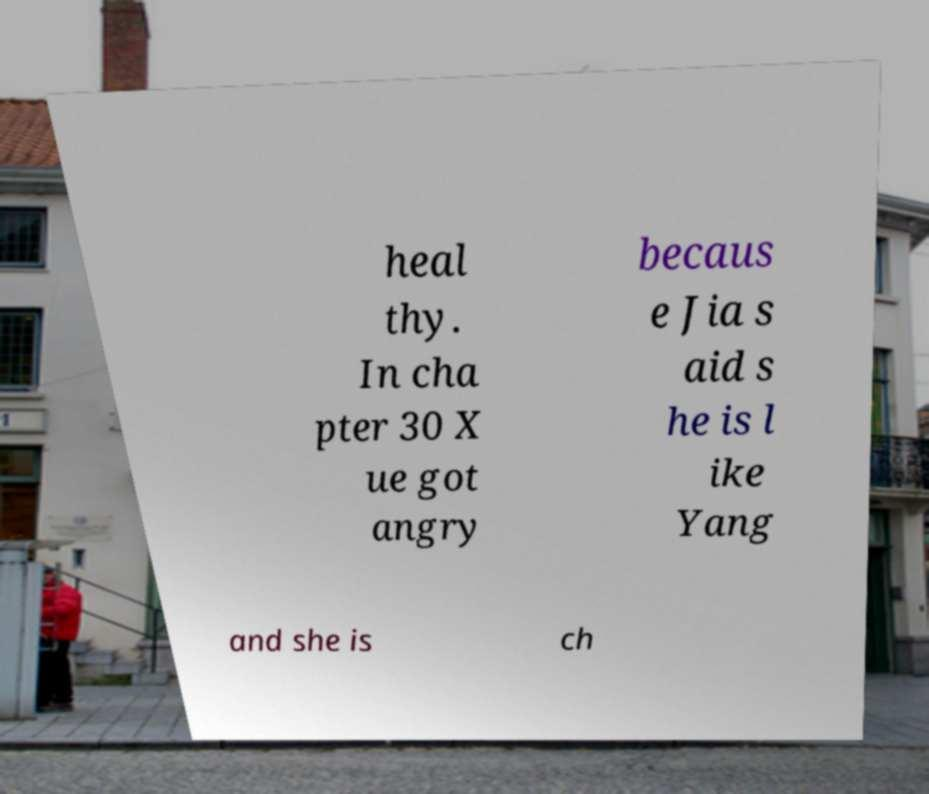Could you assist in decoding the text presented in this image and type it out clearly? heal thy. In cha pter 30 X ue got angry becaus e Jia s aid s he is l ike Yang and she is ch 